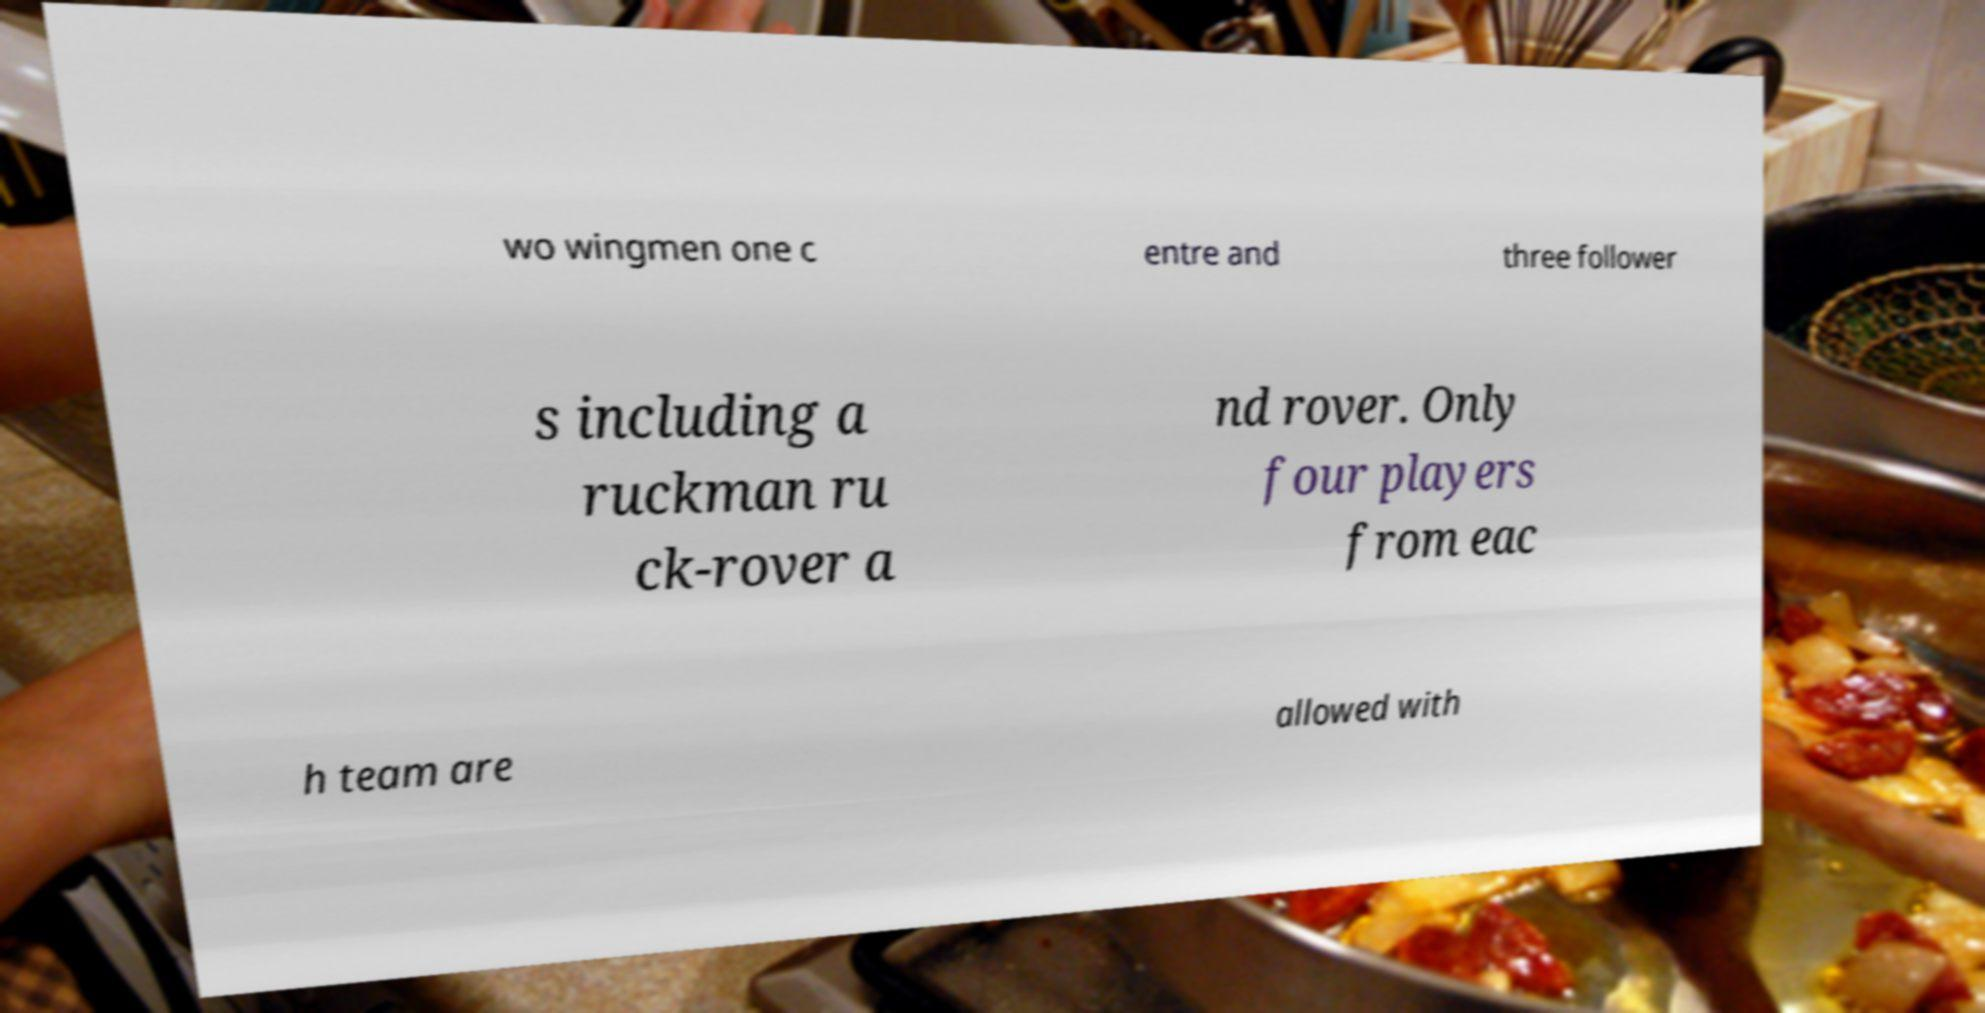Could you assist in decoding the text presented in this image and type it out clearly? wo wingmen one c entre and three follower s including a ruckman ru ck-rover a nd rover. Only four players from eac h team are allowed with 